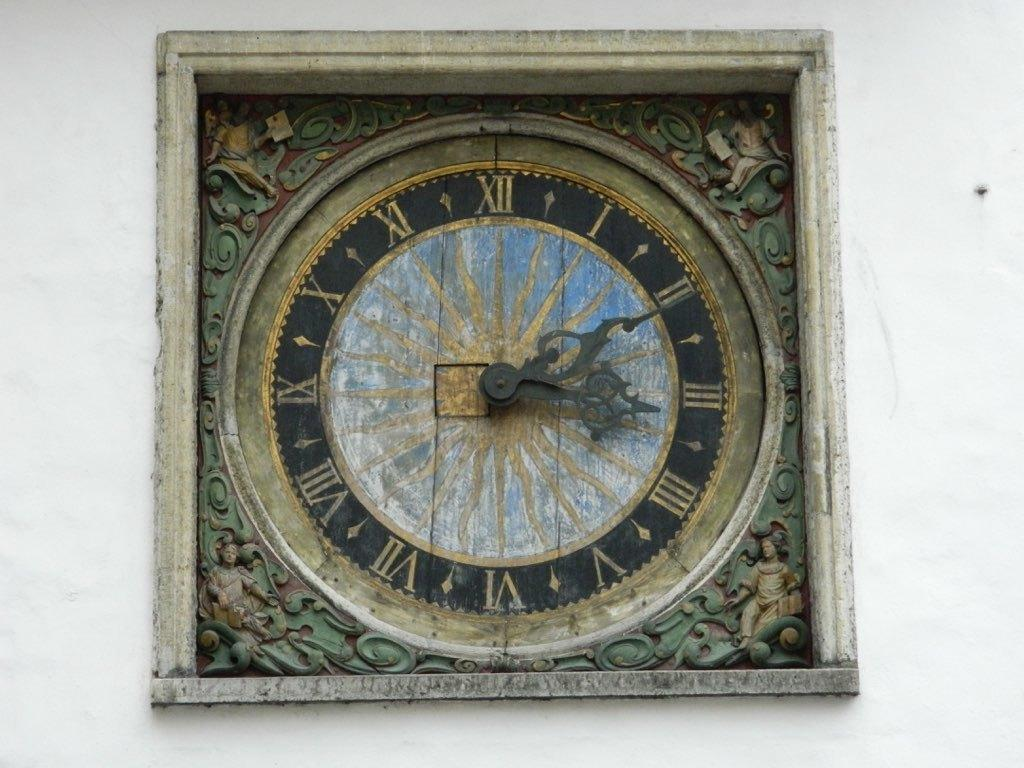<image>
Create a compact narrative representing the image presented. An antique looking wall clock, with an image of a sun in the center, reads the time 3:11. 